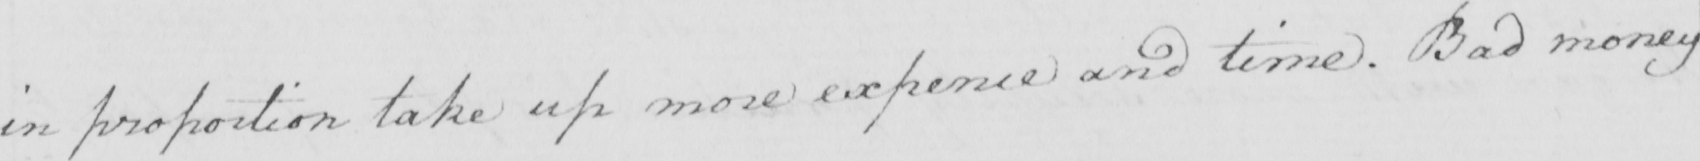Can you tell me what this handwritten text says? in proportion take up more expence and time . Bad money 